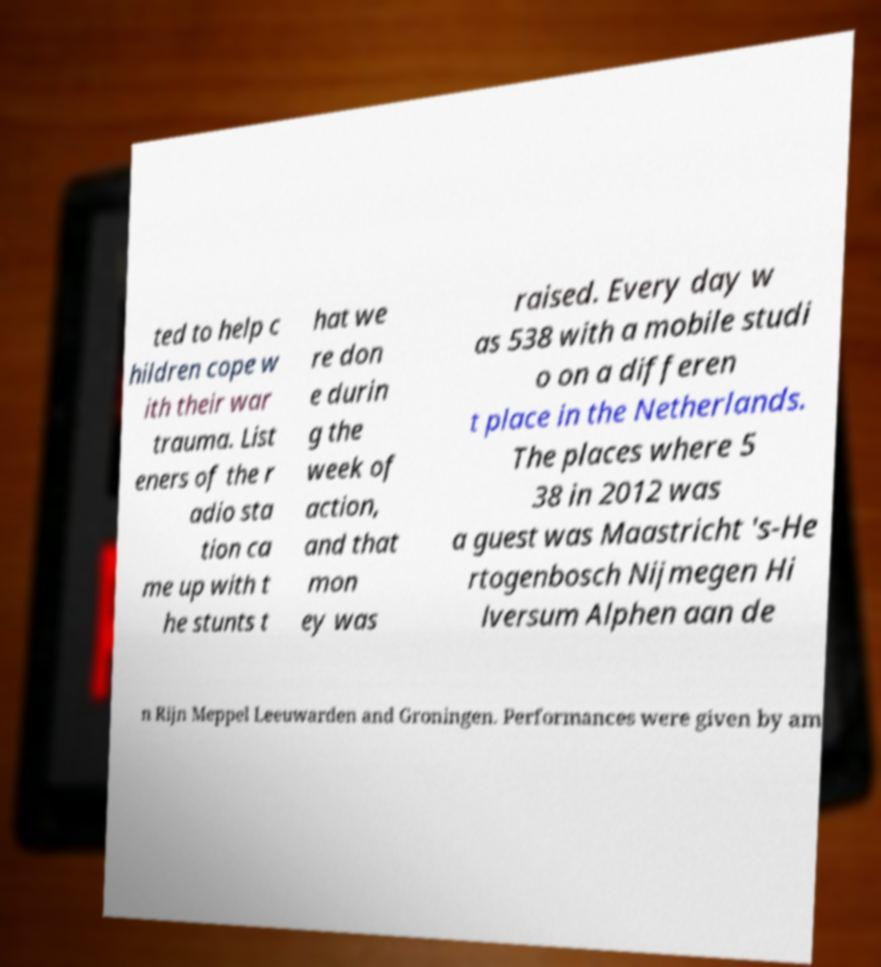Can you accurately transcribe the text from the provided image for me? ted to help c hildren cope w ith their war trauma. List eners of the r adio sta tion ca me up with t he stunts t hat we re don e durin g the week of action, and that mon ey was raised. Every day w as 538 with a mobile studi o on a differen t place in the Netherlands. The places where 5 38 in 2012 was a guest was Maastricht 's-He rtogenbosch Nijmegen Hi lversum Alphen aan de n Rijn Meppel Leeuwarden and Groningen. Performances were given by am 